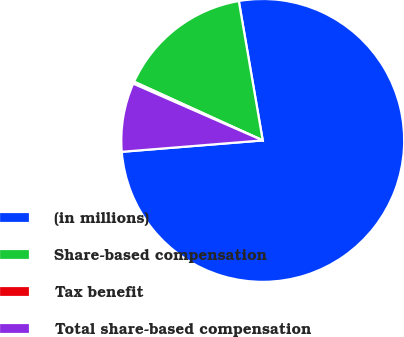Convert chart. <chart><loc_0><loc_0><loc_500><loc_500><pie_chart><fcel>(in millions)<fcel>Share-based compensation<fcel>Tax benefit<fcel>Total share-based compensation<nl><fcel>76.43%<fcel>15.48%<fcel>0.24%<fcel>7.86%<nl></chart> 